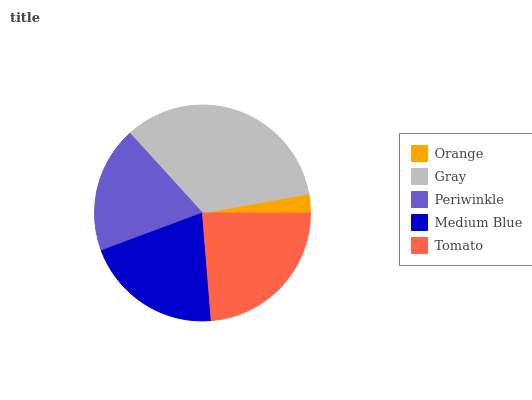Is Orange the minimum?
Answer yes or no. Yes. Is Gray the maximum?
Answer yes or no. Yes. Is Periwinkle the minimum?
Answer yes or no. No. Is Periwinkle the maximum?
Answer yes or no. No. Is Gray greater than Periwinkle?
Answer yes or no. Yes. Is Periwinkle less than Gray?
Answer yes or no. Yes. Is Periwinkle greater than Gray?
Answer yes or no. No. Is Gray less than Periwinkle?
Answer yes or no. No. Is Medium Blue the high median?
Answer yes or no. Yes. Is Medium Blue the low median?
Answer yes or no. Yes. Is Orange the high median?
Answer yes or no. No. Is Orange the low median?
Answer yes or no. No. 